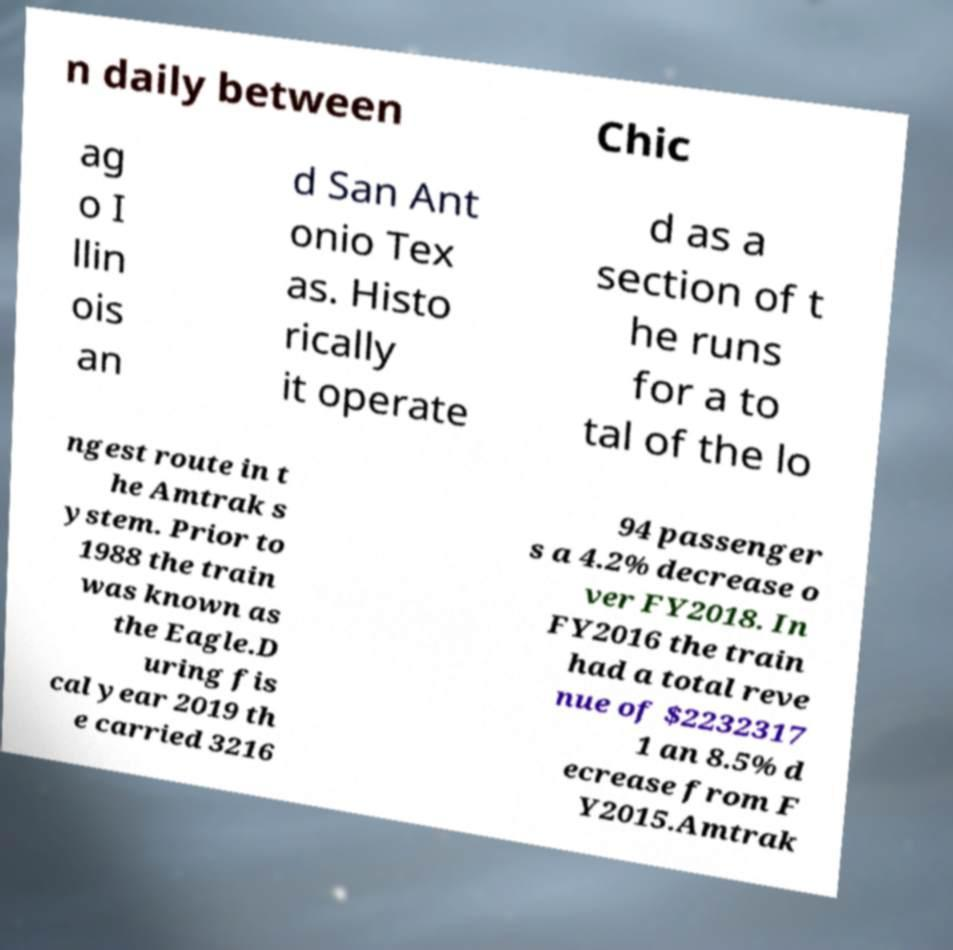For documentation purposes, I need the text within this image transcribed. Could you provide that? n daily between Chic ag o I llin ois an d San Ant onio Tex as. Histo rically it operate d as a section of t he runs for a to tal of the lo ngest route in t he Amtrak s ystem. Prior to 1988 the train was known as the Eagle.D uring fis cal year 2019 th e carried 3216 94 passenger s a 4.2% decrease o ver FY2018. In FY2016 the train had a total reve nue of $2232317 1 an 8.5% d ecrease from F Y2015.Amtrak 